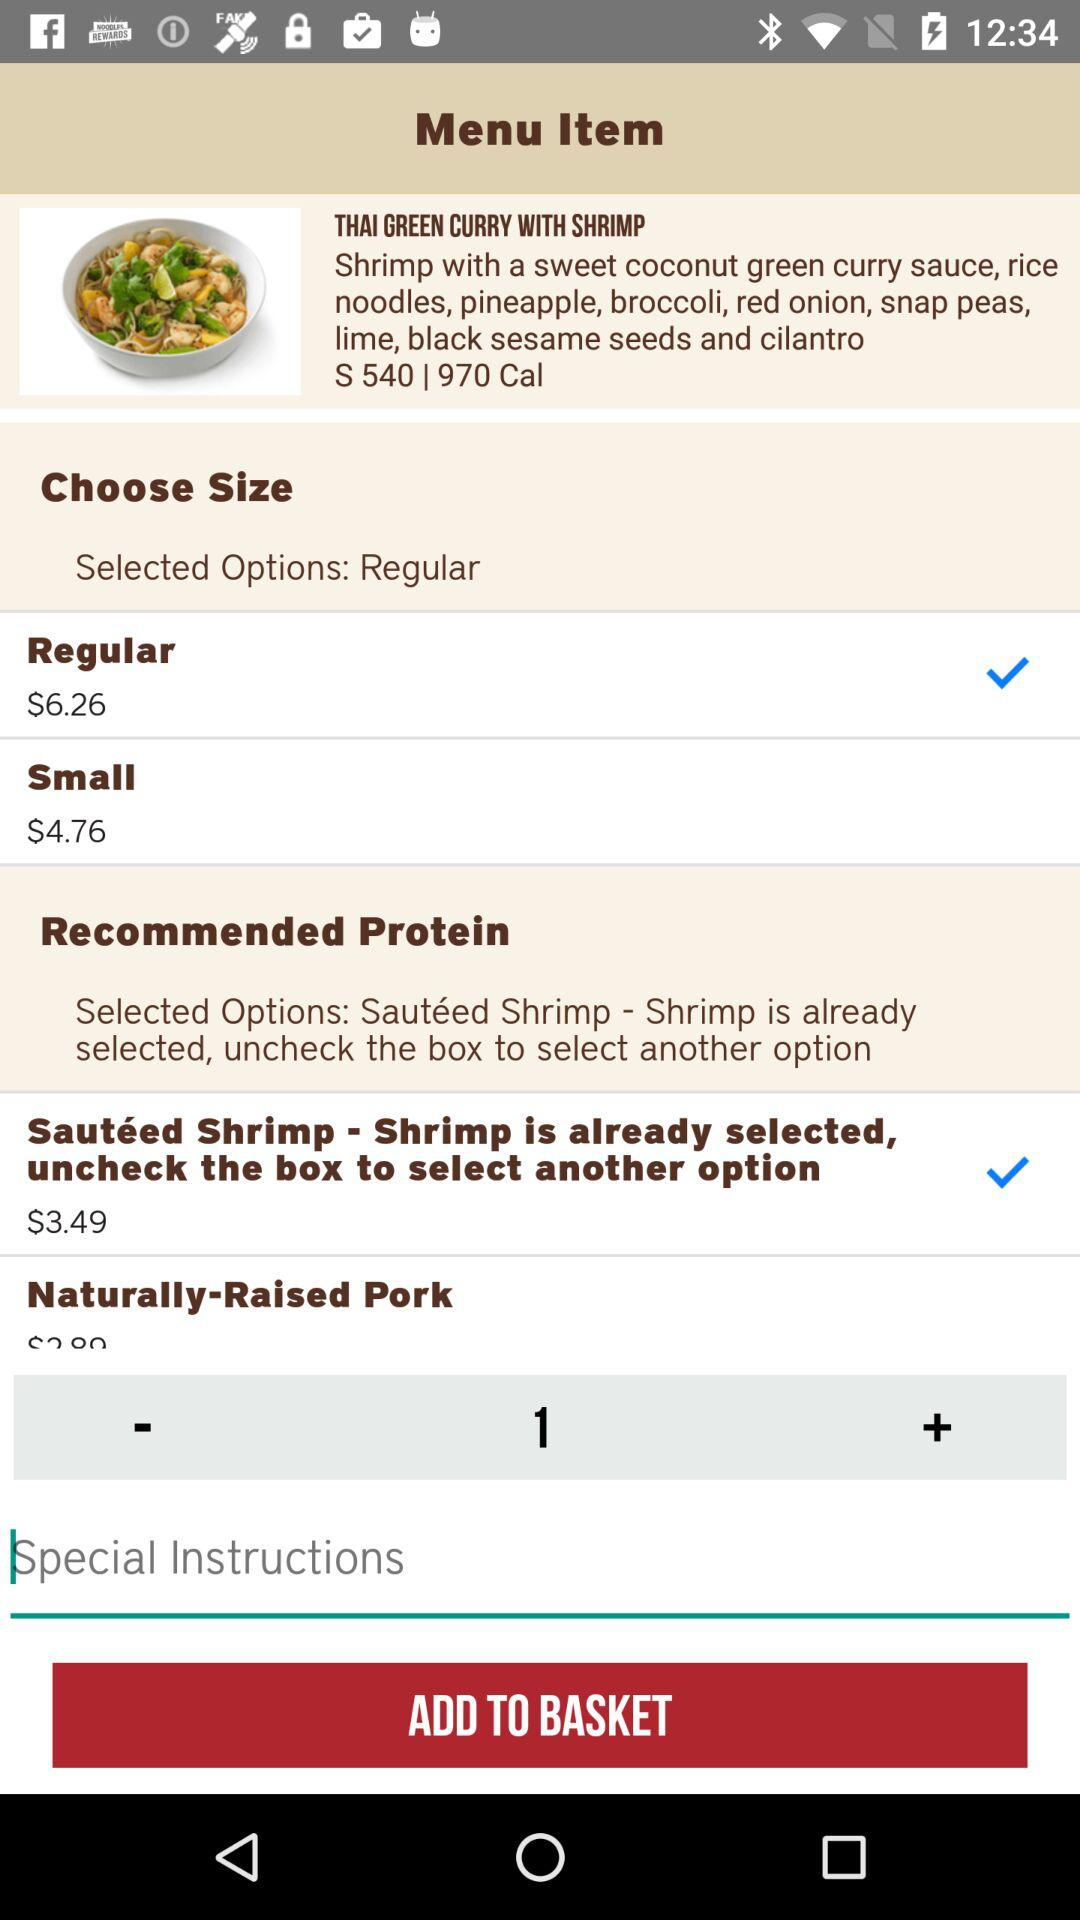What is the dish name? The dish name is "THAI GREEN CURRY WITH SHRIMP". 